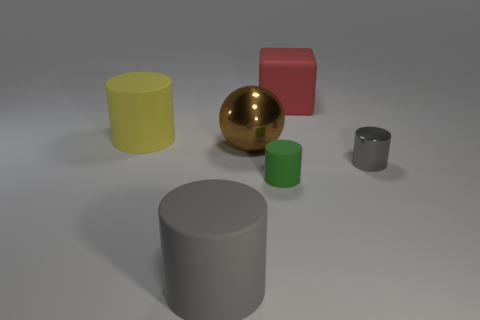Subtract all small gray cylinders. How many cylinders are left? 3 Add 4 large gray objects. How many objects exist? 10 Subtract all yellow cylinders. How many cylinders are left? 3 Subtract all green cubes. How many gray cylinders are left? 2 Subtract 3 cylinders. How many cylinders are left? 1 Subtract all cubes. How many objects are left? 5 Add 2 rubber objects. How many rubber objects exist? 6 Subtract 0 yellow spheres. How many objects are left? 6 Subtract all red balls. Subtract all red cylinders. How many balls are left? 1 Subtract all large yellow cylinders. Subtract all big gray objects. How many objects are left? 4 